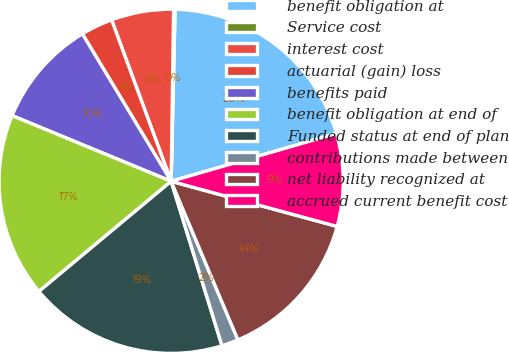<chart> <loc_0><loc_0><loc_500><loc_500><pie_chart><fcel>benefit obligation at<fcel>Service cost<fcel>interest cost<fcel>actuarial (gain) loss<fcel>benefits paid<fcel>benefit obligation at end of<fcel>Funded status at end of plan<fcel>contributions made between<fcel>net liability recognized at<fcel>accrued current benefit cost<nl><fcel>20.15%<fcel>0.14%<fcel>5.85%<fcel>3.0%<fcel>10.14%<fcel>17.29%<fcel>18.72%<fcel>1.57%<fcel>14.43%<fcel>8.71%<nl></chart> 